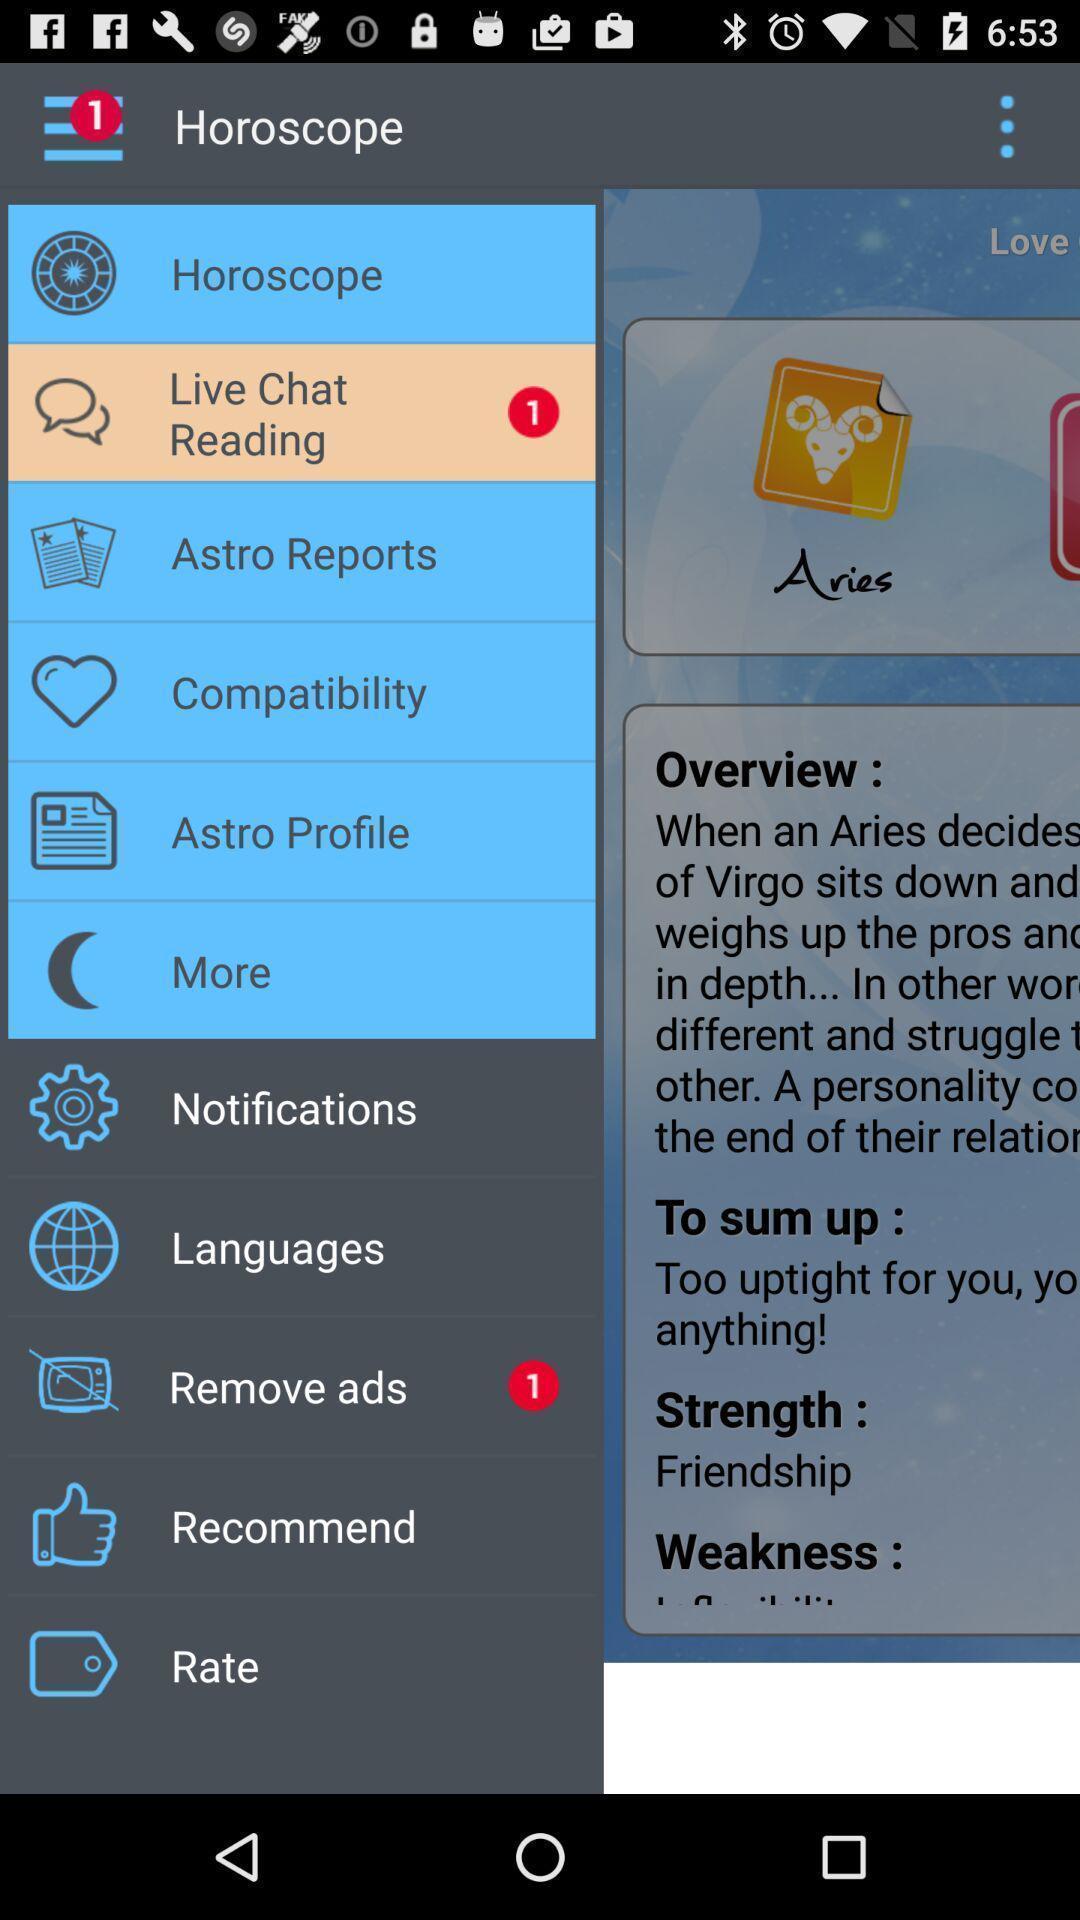Describe the content in this image. Screen shows horoscope details. 